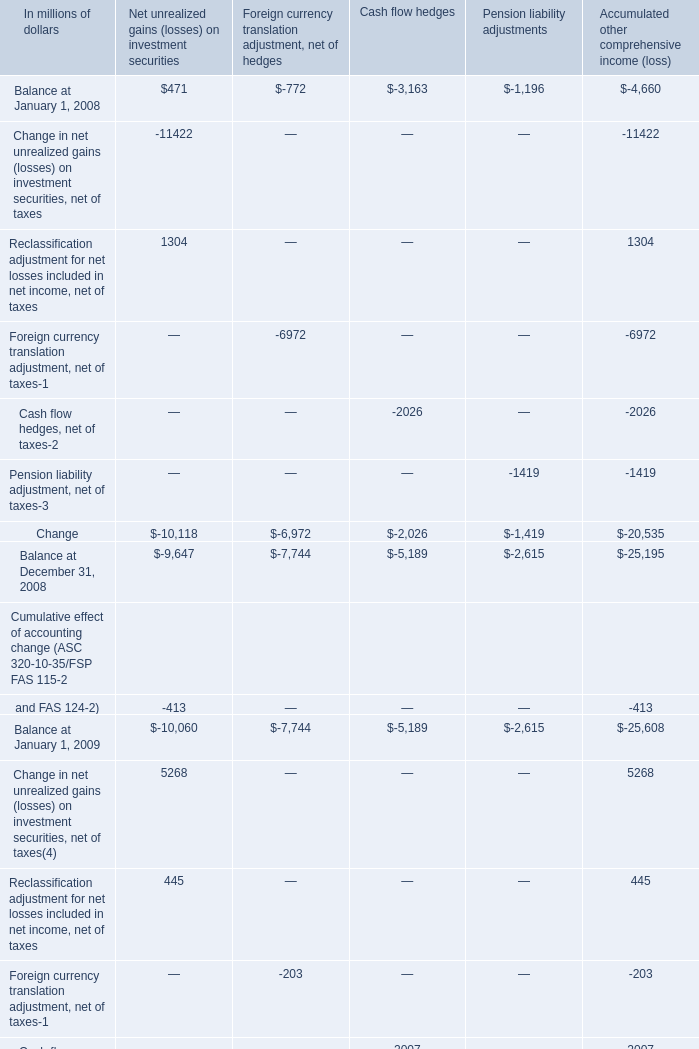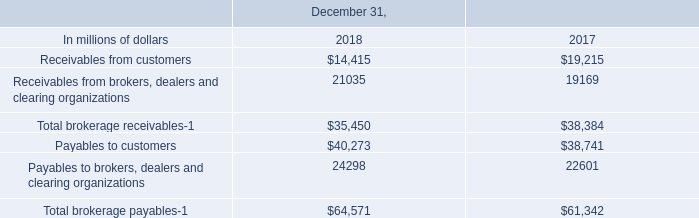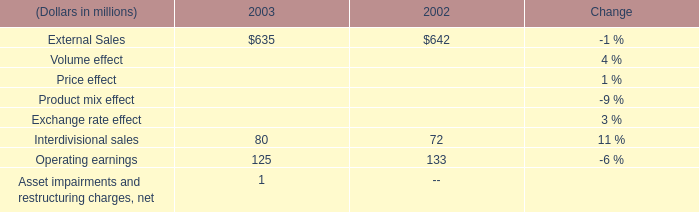What is the total amount of Balance at January 1, 2008 of Pension liability adjustments, and Payables to customers of December 31, 2018 ? 
Computations: (1196.0 + 40273.0)
Answer: 41469.0. 